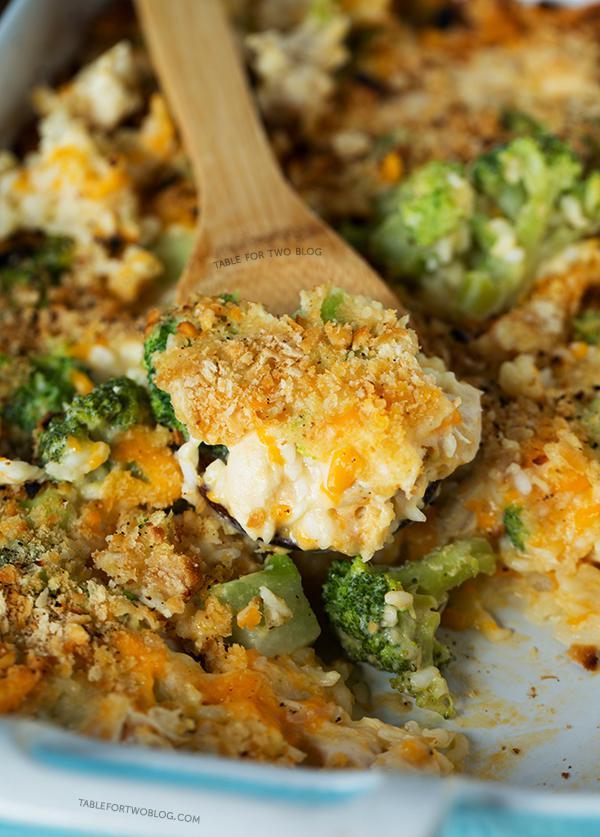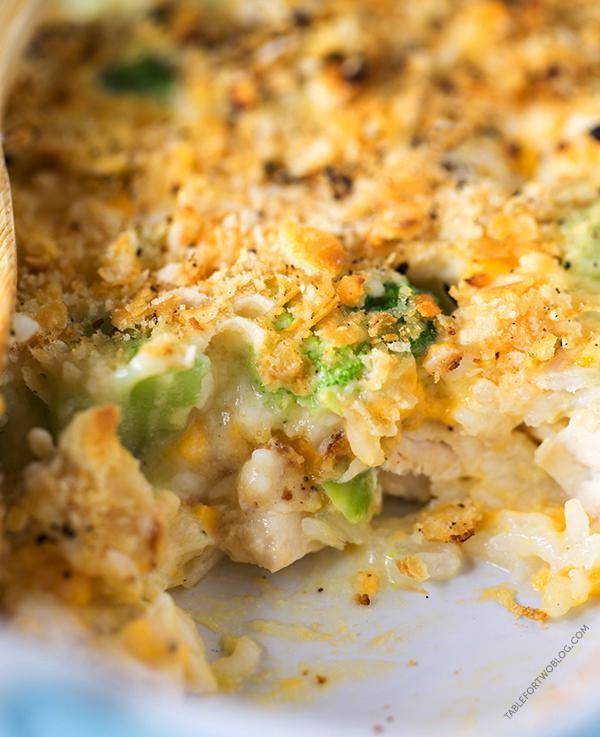The first image is the image on the left, the second image is the image on the right. Evaluate the accuracy of this statement regarding the images: "In one image, the casserole is intact, and in the other image, part of it has been served and a wooden spoon can be seen.". Is it true? Answer yes or no. No. 